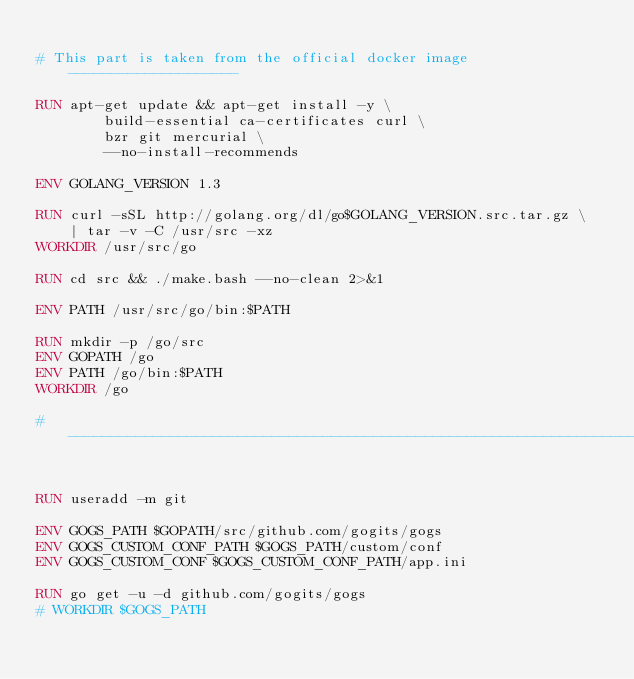<code> <loc_0><loc_0><loc_500><loc_500><_Dockerfile_>
# This part is taken from the official docker image --------------------

RUN apt-get update && apt-get install -y \
		build-essential ca-certificates curl \
		bzr git mercurial \
		--no-install-recommends

ENV GOLANG_VERSION 1.3

RUN curl -sSL http://golang.org/dl/go$GOLANG_VERSION.src.tar.gz \
	| tar -v -C /usr/src -xz
WORKDIR /usr/src/go

RUN cd src && ./make.bash --no-clean 2>&1

ENV PATH /usr/src/go/bin:$PATH

RUN mkdir -p /go/src
ENV GOPATH /go
ENV PATH /go/bin:$PATH
WORKDIR /go

# ----------------------------------------------------------------------


RUN useradd -m git

ENV GOGS_PATH $GOPATH/src/github.com/gogits/gogs
ENV GOGS_CUSTOM_CONF_PATH $GOGS_PATH/custom/conf
ENV GOGS_CUSTOM_CONF $GOGS_CUSTOM_CONF_PATH/app.ini

RUN go get -u -d github.com/gogits/gogs
# WORKDIR $GOGS_PATH</code> 